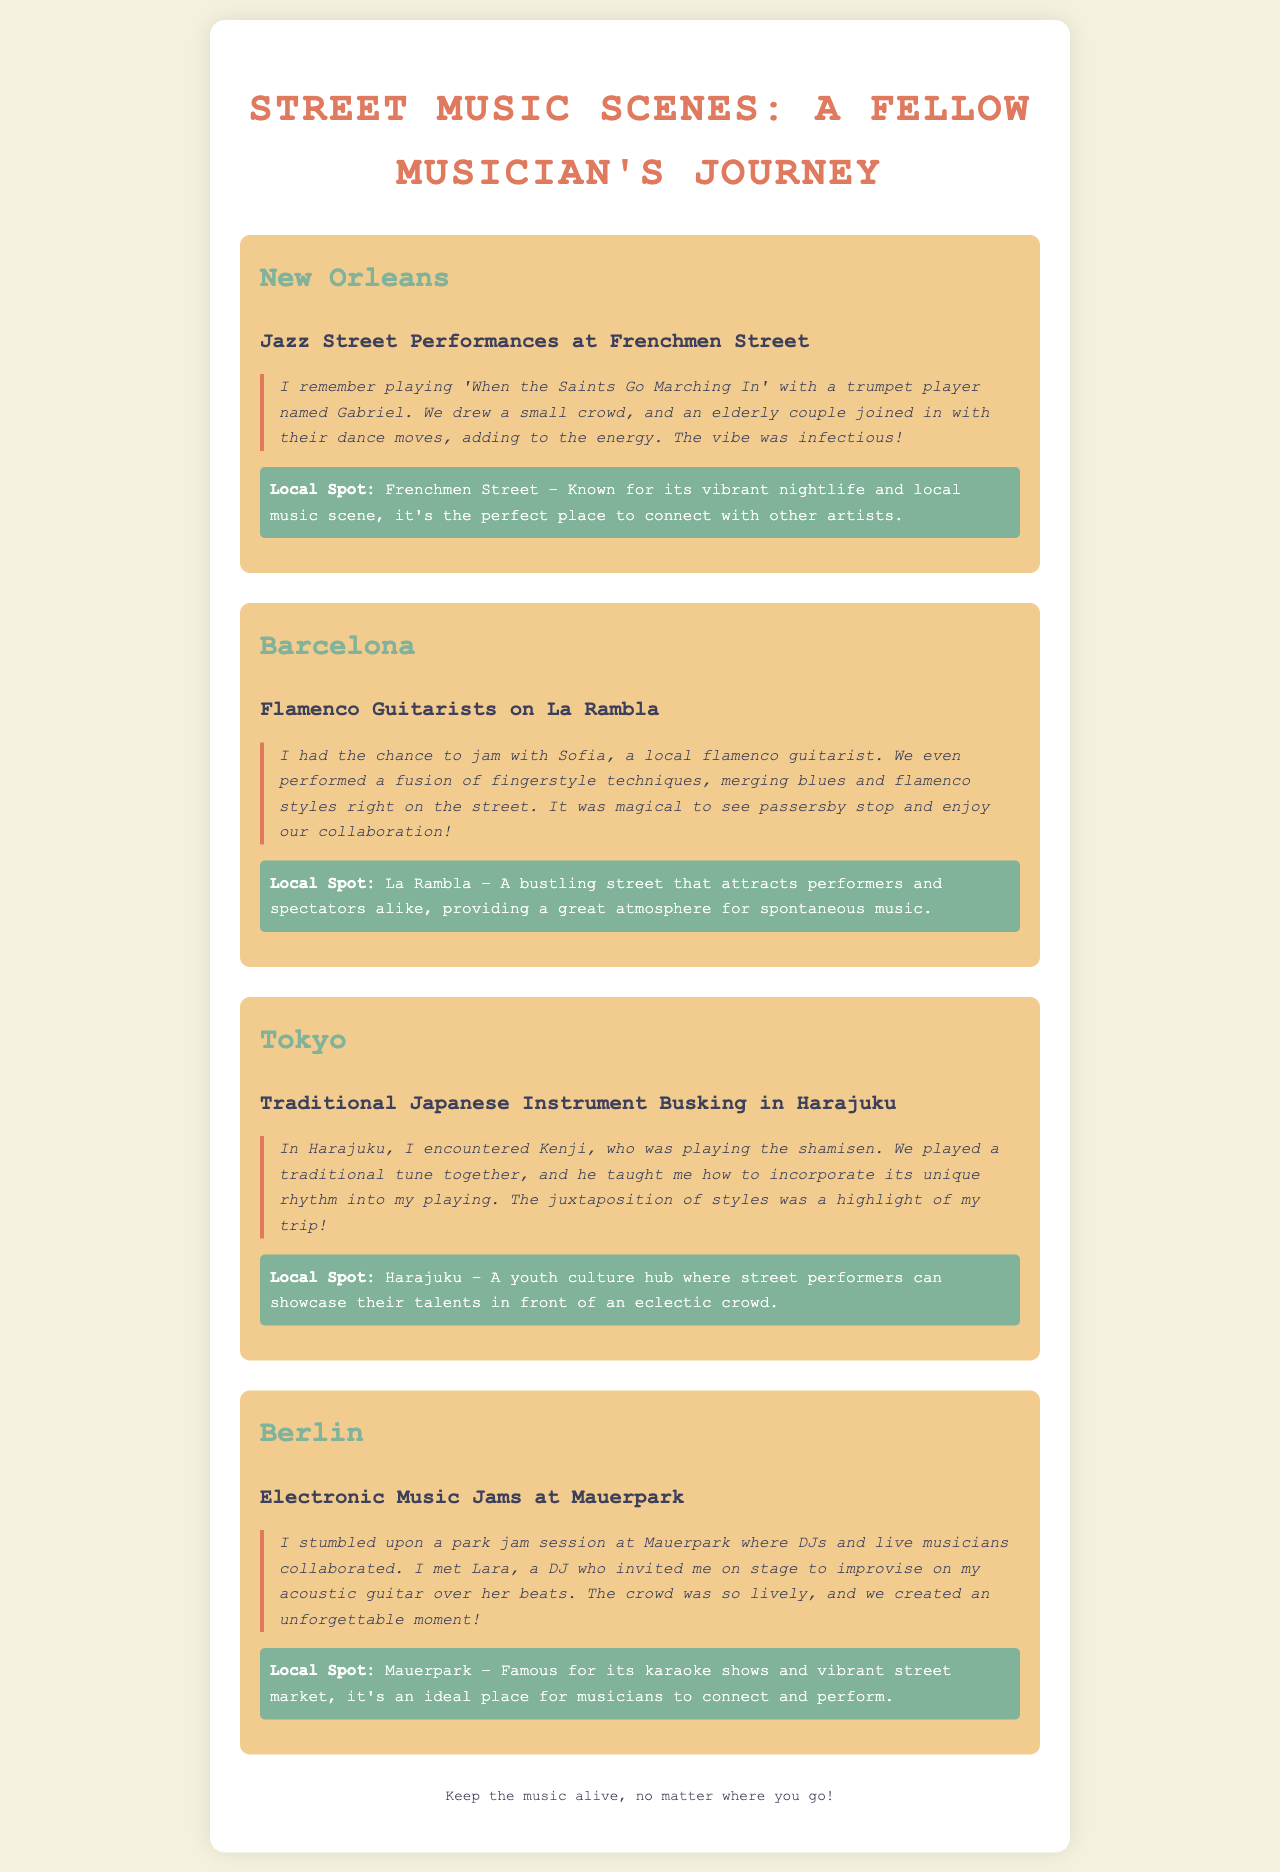What is the first city mentioned in the travel log? The first city listed in the document is 'New Orleans'.
Answer: New Orleans What type of street performances are highlighted in Barcelona? The document states that flamenco guitarists perform on La Rambla.
Answer: Flamenco Guitarists Who did the author play with in New Orleans? The author mentions playing with a trumpet player named Gabriel.
Answer: Gabriel What unique instrument was played by Kenji in Tokyo? Kenji played the shamisen during their interaction in Harajuku.
Answer: Shamisen What kind of music collaboration took place at Mauerpark? The collaboration involved DJs and live musicians improvising together.
Answer: Electronic Music Jams Which city is known for its vibrant nightlife and local music scene? The document specifies that New Orleans is known for this feature.
Answer: New Orleans In which city did the author incorporate unique rhythms into their playing? Unique rhythms were incorporated in the author's playing session with Kenji in Tokyo.
Answer: Tokyo What is the atmosphere like on La Rambla according to the author? The author describes La Rambla as a bustling street that attracts performers and spectators.
Answer: Bustling Which instrument did the author use to jam in Berlin? The author played an acoustic guitar during the jam session at Mauerpark.
Answer: Acoustic Guitar 